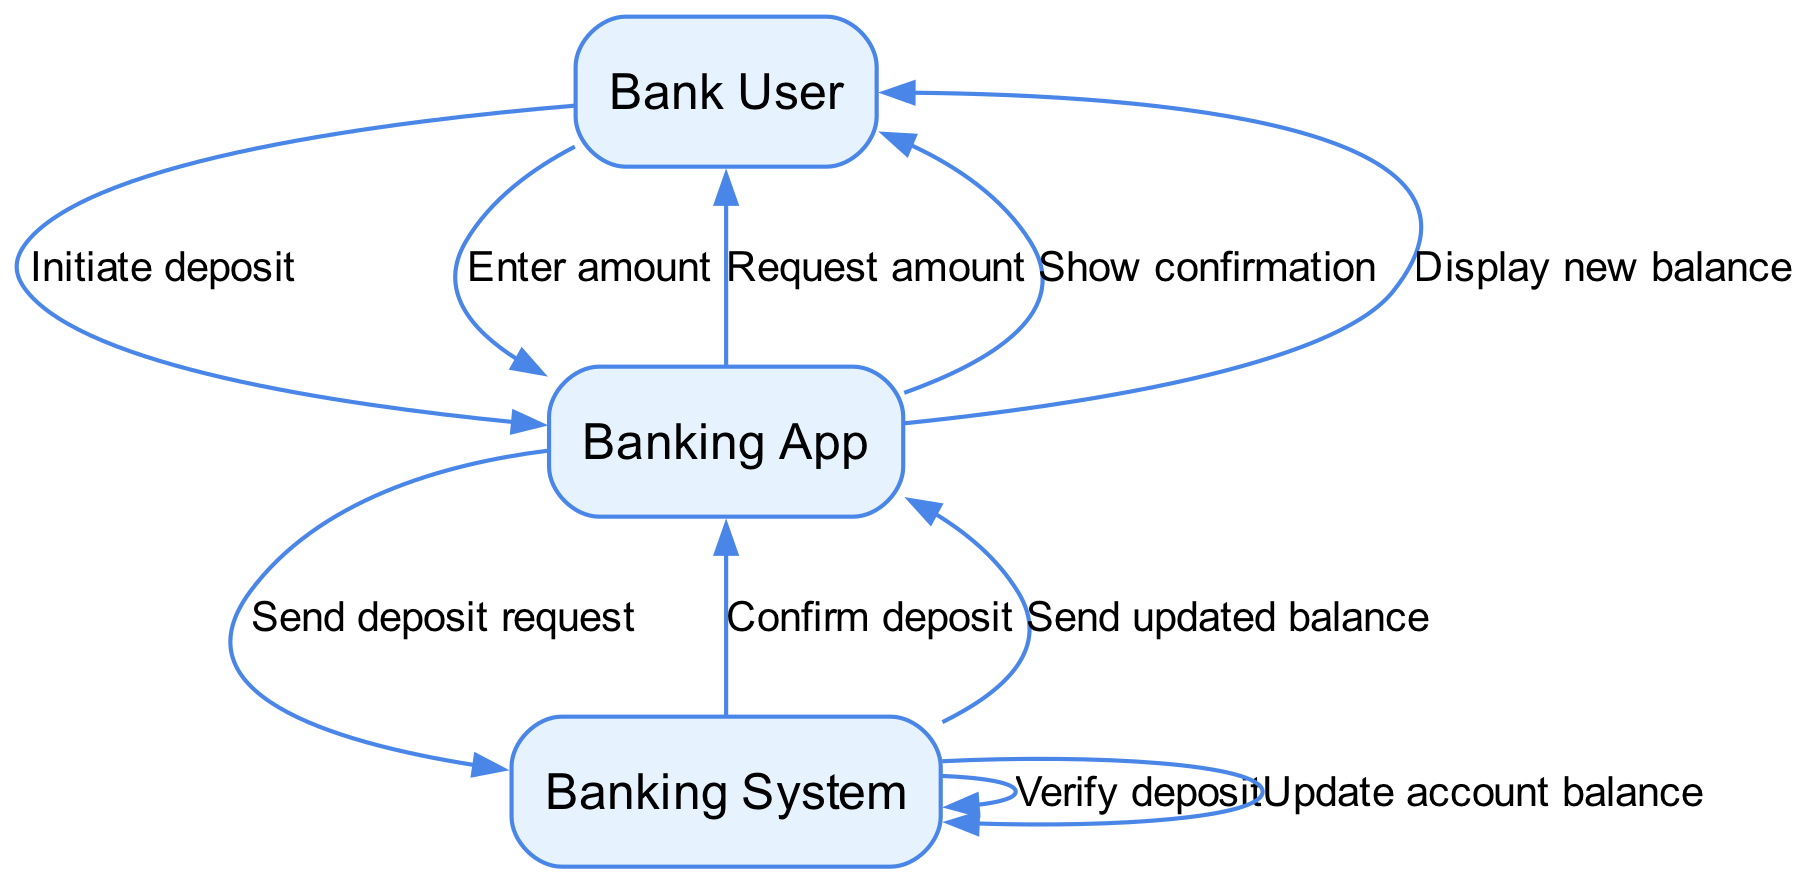What is the first action in the process? The first action is the "Initiate deposit" from the Bank User to the Banking App, marking the beginning of the deposit transaction.
Answer: Initiate deposit How many nodes are present in the diagram? The diagram contains 8 nodes: Bank User, Banking App, Deposit Transaction, Amount Entered, Deposit Confirmation, Banking System, Verification Process, and Account Balance Update. Counting each participant and step provides this total.
Answer: 8 What does the Banking App request from the Bank User after the deposit initiation? After the deposit initiation, the Banking App requests the amount to be deposited, which is the next step in the transaction process.
Answer: Request amount Which entity sends the deposit request to the Banking System? The Banking App is responsible for sending the deposit request to the Banking System, which processes the transaction.
Answer: Banking App What happens after the Banking System verifies the deposit? After verification, the Banking System updates the account balance and then sends the updated balance to the Banking App. This is a continuation of the deposit process.
Answer: Update account balance What is the final confirmation sent to the user? The final confirmation sent to the user indicates the deposit was successful and displays the new balance, completing the process.
Answer: Display new balance What action leads to the adjustment of the user's savings account balance? The adjustment of the user's balance occurs after the verification process is complete, specifically during the account balance update step.
Answer: Update account balance What is the status of the deposit after the Banking App shows confirmation? The deposit is confirmed successful after the Banking App shows confirmation, indicating a completed transaction.
Answer: Show confirmation What are the last two steps involving the Banking System in the sequence? The last two steps involving the Banking System are "Update account balance" followed by "Send updated balance" to the Banking App before the final confirmation is shown to the user.
Answer: Update account balance, Send updated balance 